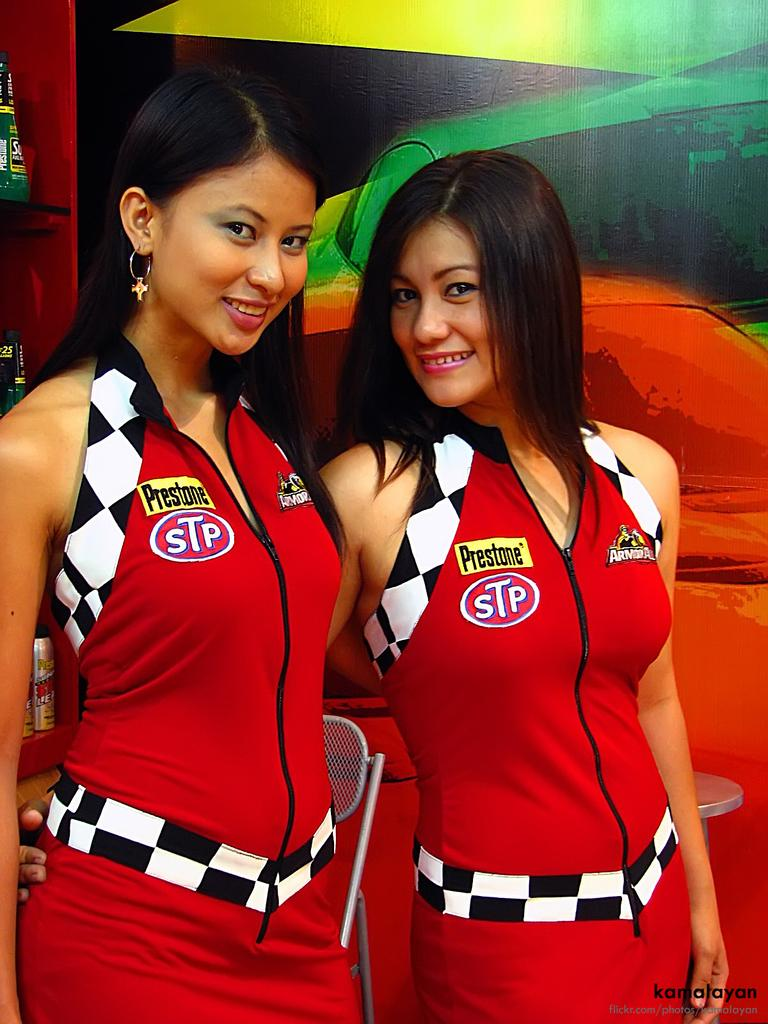<image>
Relay a brief, clear account of the picture shown. two women models wearing STP Prestone shirts for racing. 